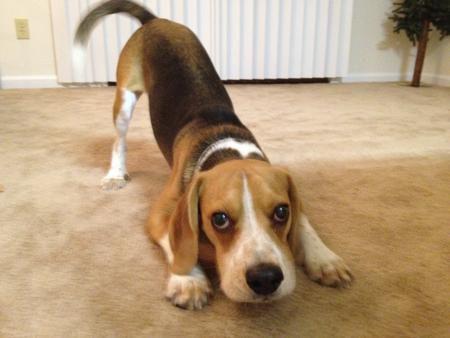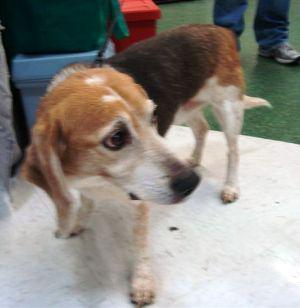The first image is the image on the left, the second image is the image on the right. Evaluate the accuracy of this statement regarding the images: "Right image shows a camera-facing beagle with its tongue at least partly showing.". Is it true? Answer yes or no. No. The first image is the image on the left, the second image is the image on the right. Examine the images to the left and right. Is the description "A dog has its tongue visible while looking at the camera." accurate? Answer yes or no. No. 